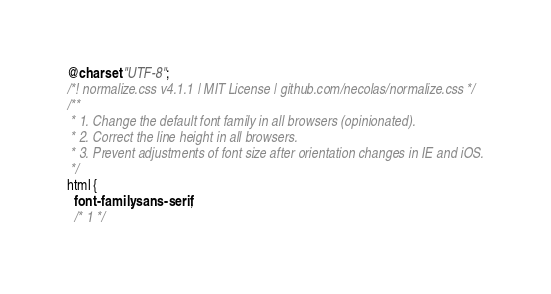<code> <loc_0><loc_0><loc_500><loc_500><_CSS_>@charset "UTF-8";
/*! normalize.css v4.1.1 | MIT License | github.com/necolas/normalize.css */
/**
 * 1. Change the default font family in all browsers (opinionated).
 * 2. Correct the line height in all browsers.
 * 3. Prevent adjustments of font size after orientation changes in IE and iOS.
 */
html {
  font-family: sans-serif;
  /* 1 */</code> 